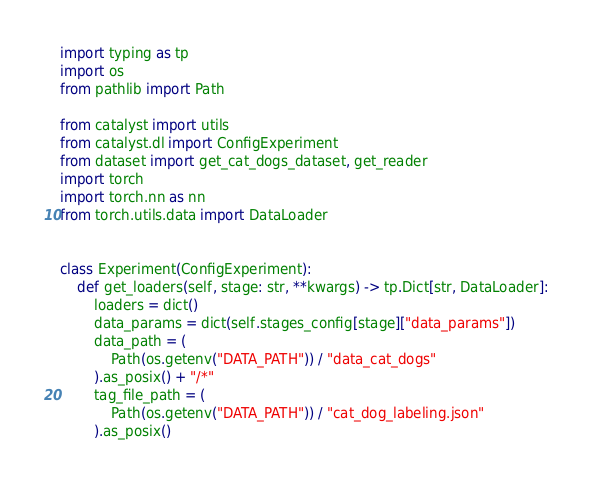Convert code to text. <code><loc_0><loc_0><loc_500><loc_500><_Python_>import typing as tp
import os
from pathlib import Path

from catalyst import utils
from catalyst.dl import ConfigExperiment
from dataset import get_cat_dogs_dataset, get_reader
import torch
import torch.nn as nn
from torch.utils.data import DataLoader


class Experiment(ConfigExperiment):
    def get_loaders(self, stage: str, **kwargs) -> tp.Dict[str, DataLoader]:
        loaders = dict()
        data_params = dict(self.stages_config[stage]["data_params"])
        data_path = (
            Path(os.getenv("DATA_PATH")) / "data_cat_dogs"
        ).as_posix() + "/*"
        tag_file_path = (
            Path(os.getenv("DATA_PATH")) / "cat_dog_labeling.json"
        ).as_posix()</code> 